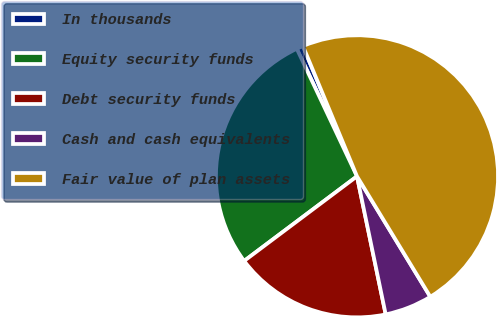Convert chart to OTSL. <chart><loc_0><loc_0><loc_500><loc_500><pie_chart><fcel>In thousands<fcel>Equity security funds<fcel>Debt security funds<fcel>Cash and cash equivalents<fcel>Fair value of plan assets<nl><fcel>0.76%<fcel>28.22%<fcel>18.02%<fcel>5.44%<fcel>47.56%<nl></chart> 